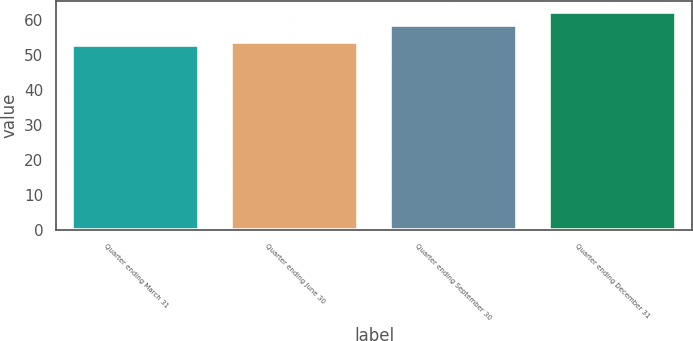<chart> <loc_0><loc_0><loc_500><loc_500><bar_chart><fcel>Quarter ending March 31<fcel>Quarter ending June 30<fcel>Quarter ending September 30<fcel>Quarter ending December 31<nl><fcel>52.88<fcel>53.89<fcel>58.8<fcel>62.37<nl></chart> 